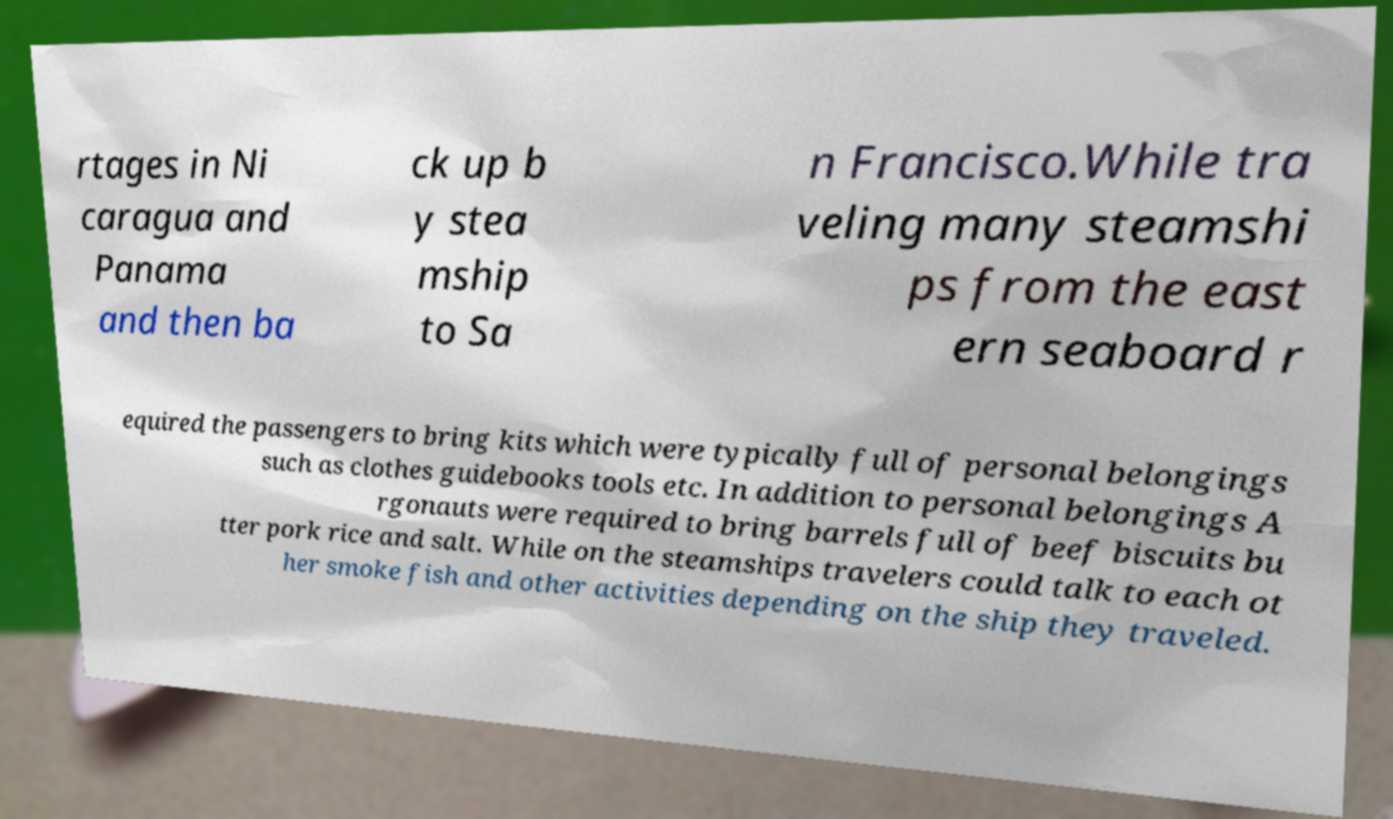Could you assist in decoding the text presented in this image and type it out clearly? rtages in Ni caragua and Panama and then ba ck up b y stea mship to Sa n Francisco.While tra veling many steamshi ps from the east ern seaboard r equired the passengers to bring kits which were typically full of personal belongings such as clothes guidebooks tools etc. In addition to personal belongings A rgonauts were required to bring barrels full of beef biscuits bu tter pork rice and salt. While on the steamships travelers could talk to each ot her smoke fish and other activities depending on the ship they traveled. 